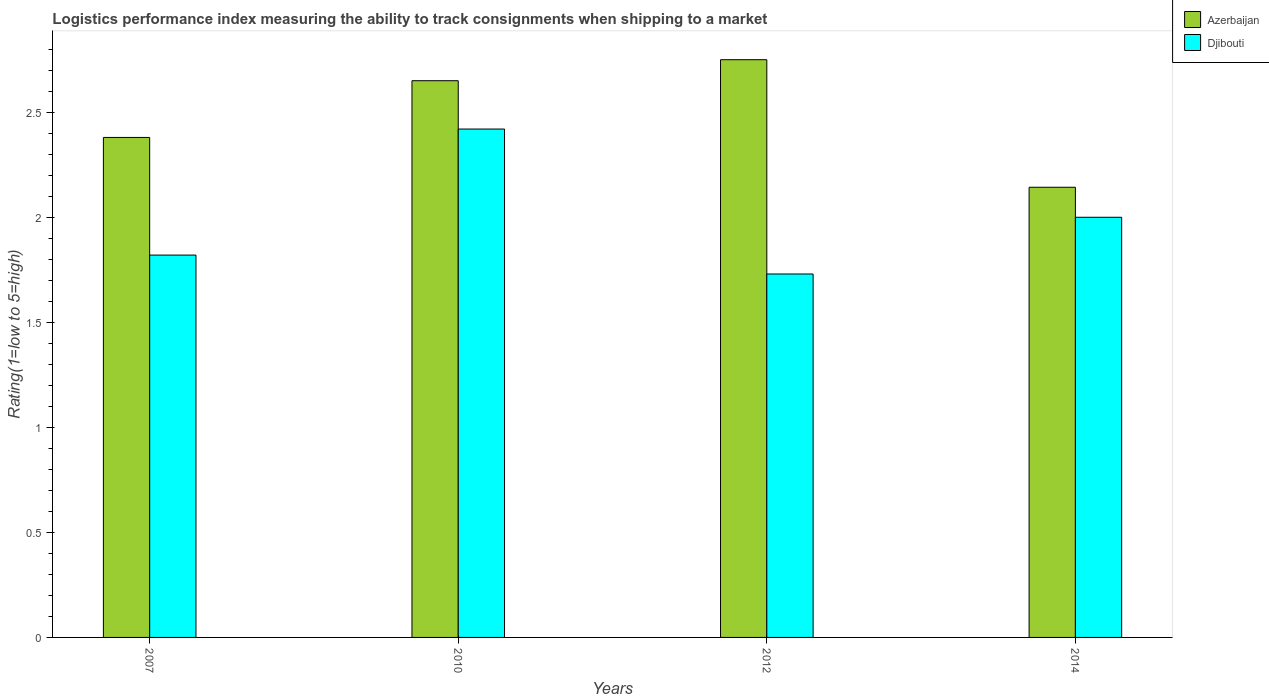How many groups of bars are there?
Your answer should be very brief. 4. Are the number of bars on each tick of the X-axis equal?
Offer a very short reply. Yes. How many bars are there on the 3rd tick from the left?
Ensure brevity in your answer.  2. How many bars are there on the 2nd tick from the right?
Make the answer very short. 2. What is the label of the 3rd group of bars from the left?
Keep it short and to the point. 2012. What is the Logistic performance index in Djibouti in 2014?
Offer a very short reply. 2. Across all years, what is the maximum Logistic performance index in Djibouti?
Make the answer very short. 2.42. Across all years, what is the minimum Logistic performance index in Azerbaijan?
Offer a very short reply. 2.14. In which year was the Logistic performance index in Azerbaijan minimum?
Keep it short and to the point. 2014. What is the total Logistic performance index in Azerbaijan in the graph?
Ensure brevity in your answer.  9.92. What is the difference between the Logistic performance index in Djibouti in 2007 and that in 2014?
Give a very brief answer. -0.18. What is the difference between the Logistic performance index in Djibouti in 2007 and the Logistic performance index in Azerbaijan in 2014?
Your answer should be very brief. -0.32. What is the average Logistic performance index in Azerbaijan per year?
Provide a succinct answer. 2.48. In the year 2014, what is the difference between the Logistic performance index in Azerbaijan and Logistic performance index in Djibouti?
Make the answer very short. 0.14. What is the ratio of the Logistic performance index in Azerbaijan in 2012 to that in 2014?
Ensure brevity in your answer.  1.28. Is the Logistic performance index in Djibouti in 2007 less than that in 2010?
Provide a succinct answer. Yes. Is the difference between the Logistic performance index in Azerbaijan in 2007 and 2014 greater than the difference between the Logistic performance index in Djibouti in 2007 and 2014?
Your response must be concise. Yes. What is the difference between the highest and the second highest Logistic performance index in Azerbaijan?
Give a very brief answer. 0.1. What is the difference between the highest and the lowest Logistic performance index in Azerbaijan?
Provide a succinct answer. 0.61. Is the sum of the Logistic performance index in Azerbaijan in 2007 and 2012 greater than the maximum Logistic performance index in Djibouti across all years?
Your answer should be compact. Yes. What does the 1st bar from the left in 2012 represents?
Make the answer very short. Azerbaijan. What does the 1st bar from the right in 2014 represents?
Ensure brevity in your answer.  Djibouti. How many bars are there?
Keep it short and to the point. 8. Are the values on the major ticks of Y-axis written in scientific E-notation?
Offer a terse response. No. Does the graph contain grids?
Your answer should be very brief. No. Where does the legend appear in the graph?
Your answer should be compact. Top right. How many legend labels are there?
Offer a very short reply. 2. How are the legend labels stacked?
Your response must be concise. Vertical. What is the title of the graph?
Your response must be concise. Logistics performance index measuring the ability to track consignments when shipping to a market. Does "Italy" appear as one of the legend labels in the graph?
Provide a short and direct response. No. What is the label or title of the Y-axis?
Your answer should be very brief. Rating(1=low to 5=high). What is the Rating(1=low to 5=high) in Azerbaijan in 2007?
Your response must be concise. 2.38. What is the Rating(1=low to 5=high) of Djibouti in 2007?
Make the answer very short. 1.82. What is the Rating(1=low to 5=high) of Azerbaijan in 2010?
Keep it short and to the point. 2.65. What is the Rating(1=low to 5=high) of Djibouti in 2010?
Your answer should be very brief. 2.42. What is the Rating(1=low to 5=high) in Azerbaijan in 2012?
Your answer should be very brief. 2.75. What is the Rating(1=low to 5=high) in Djibouti in 2012?
Your answer should be compact. 1.73. What is the Rating(1=low to 5=high) of Azerbaijan in 2014?
Give a very brief answer. 2.14. Across all years, what is the maximum Rating(1=low to 5=high) of Azerbaijan?
Keep it short and to the point. 2.75. Across all years, what is the maximum Rating(1=low to 5=high) in Djibouti?
Give a very brief answer. 2.42. Across all years, what is the minimum Rating(1=low to 5=high) of Azerbaijan?
Provide a short and direct response. 2.14. Across all years, what is the minimum Rating(1=low to 5=high) of Djibouti?
Offer a terse response. 1.73. What is the total Rating(1=low to 5=high) of Azerbaijan in the graph?
Ensure brevity in your answer.  9.92. What is the total Rating(1=low to 5=high) in Djibouti in the graph?
Keep it short and to the point. 7.97. What is the difference between the Rating(1=low to 5=high) in Azerbaijan in 2007 and that in 2010?
Give a very brief answer. -0.27. What is the difference between the Rating(1=low to 5=high) of Djibouti in 2007 and that in 2010?
Your answer should be compact. -0.6. What is the difference between the Rating(1=low to 5=high) of Azerbaijan in 2007 and that in 2012?
Make the answer very short. -0.37. What is the difference between the Rating(1=low to 5=high) of Djibouti in 2007 and that in 2012?
Give a very brief answer. 0.09. What is the difference between the Rating(1=low to 5=high) of Azerbaijan in 2007 and that in 2014?
Your answer should be compact. 0.24. What is the difference between the Rating(1=low to 5=high) in Djibouti in 2007 and that in 2014?
Keep it short and to the point. -0.18. What is the difference between the Rating(1=low to 5=high) of Azerbaijan in 2010 and that in 2012?
Make the answer very short. -0.1. What is the difference between the Rating(1=low to 5=high) of Djibouti in 2010 and that in 2012?
Offer a very short reply. 0.69. What is the difference between the Rating(1=low to 5=high) in Azerbaijan in 2010 and that in 2014?
Give a very brief answer. 0.51. What is the difference between the Rating(1=low to 5=high) in Djibouti in 2010 and that in 2014?
Give a very brief answer. 0.42. What is the difference between the Rating(1=low to 5=high) in Azerbaijan in 2012 and that in 2014?
Your response must be concise. 0.61. What is the difference between the Rating(1=low to 5=high) in Djibouti in 2012 and that in 2014?
Provide a succinct answer. -0.27. What is the difference between the Rating(1=low to 5=high) in Azerbaijan in 2007 and the Rating(1=low to 5=high) in Djibouti in 2010?
Keep it short and to the point. -0.04. What is the difference between the Rating(1=low to 5=high) in Azerbaijan in 2007 and the Rating(1=low to 5=high) in Djibouti in 2012?
Make the answer very short. 0.65. What is the difference between the Rating(1=low to 5=high) of Azerbaijan in 2007 and the Rating(1=low to 5=high) of Djibouti in 2014?
Your response must be concise. 0.38. What is the difference between the Rating(1=low to 5=high) of Azerbaijan in 2010 and the Rating(1=low to 5=high) of Djibouti in 2012?
Keep it short and to the point. 0.92. What is the difference between the Rating(1=low to 5=high) of Azerbaijan in 2010 and the Rating(1=low to 5=high) of Djibouti in 2014?
Give a very brief answer. 0.65. What is the average Rating(1=low to 5=high) in Azerbaijan per year?
Keep it short and to the point. 2.48. What is the average Rating(1=low to 5=high) of Djibouti per year?
Provide a short and direct response. 1.99. In the year 2007, what is the difference between the Rating(1=low to 5=high) of Azerbaijan and Rating(1=low to 5=high) of Djibouti?
Make the answer very short. 0.56. In the year 2010, what is the difference between the Rating(1=low to 5=high) of Azerbaijan and Rating(1=low to 5=high) of Djibouti?
Your response must be concise. 0.23. In the year 2012, what is the difference between the Rating(1=low to 5=high) in Azerbaijan and Rating(1=low to 5=high) in Djibouti?
Your response must be concise. 1.02. In the year 2014, what is the difference between the Rating(1=low to 5=high) of Azerbaijan and Rating(1=low to 5=high) of Djibouti?
Keep it short and to the point. 0.14. What is the ratio of the Rating(1=low to 5=high) of Azerbaijan in 2007 to that in 2010?
Make the answer very short. 0.9. What is the ratio of the Rating(1=low to 5=high) of Djibouti in 2007 to that in 2010?
Ensure brevity in your answer.  0.75. What is the ratio of the Rating(1=low to 5=high) in Azerbaijan in 2007 to that in 2012?
Your answer should be very brief. 0.87. What is the ratio of the Rating(1=low to 5=high) of Djibouti in 2007 to that in 2012?
Your answer should be compact. 1.05. What is the ratio of the Rating(1=low to 5=high) in Azerbaijan in 2007 to that in 2014?
Provide a short and direct response. 1.11. What is the ratio of the Rating(1=low to 5=high) of Djibouti in 2007 to that in 2014?
Your response must be concise. 0.91. What is the ratio of the Rating(1=low to 5=high) of Azerbaijan in 2010 to that in 2012?
Give a very brief answer. 0.96. What is the ratio of the Rating(1=low to 5=high) of Djibouti in 2010 to that in 2012?
Your answer should be compact. 1.4. What is the ratio of the Rating(1=low to 5=high) in Azerbaijan in 2010 to that in 2014?
Offer a very short reply. 1.24. What is the ratio of the Rating(1=low to 5=high) in Djibouti in 2010 to that in 2014?
Offer a terse response. 1.21. What is the ratio of the Rating(1=low to 5=high) in Azerbaijan in 2012 to that in 2014?
Keep it short and to the point. 1.28. What is the ratio of the Rating(1=low to 5=high) in Djibouti in 2012 to that in 2014?
Keep it short and to the point. 0.86. What is the difference between the highest and the second highest Rating(1=low to 5=high) in Djibouti?
Give a very brief answer. 0.42. What is the difference between the highest and the lowest Rating(1=low to 5=high) in Azerbaijan?
Give a very brief answer. 0.61. What is the difference between the highest and the lowest Rating(1=low to 5=high) in Djibouti?
Provide a short and direct response. 0.69. 